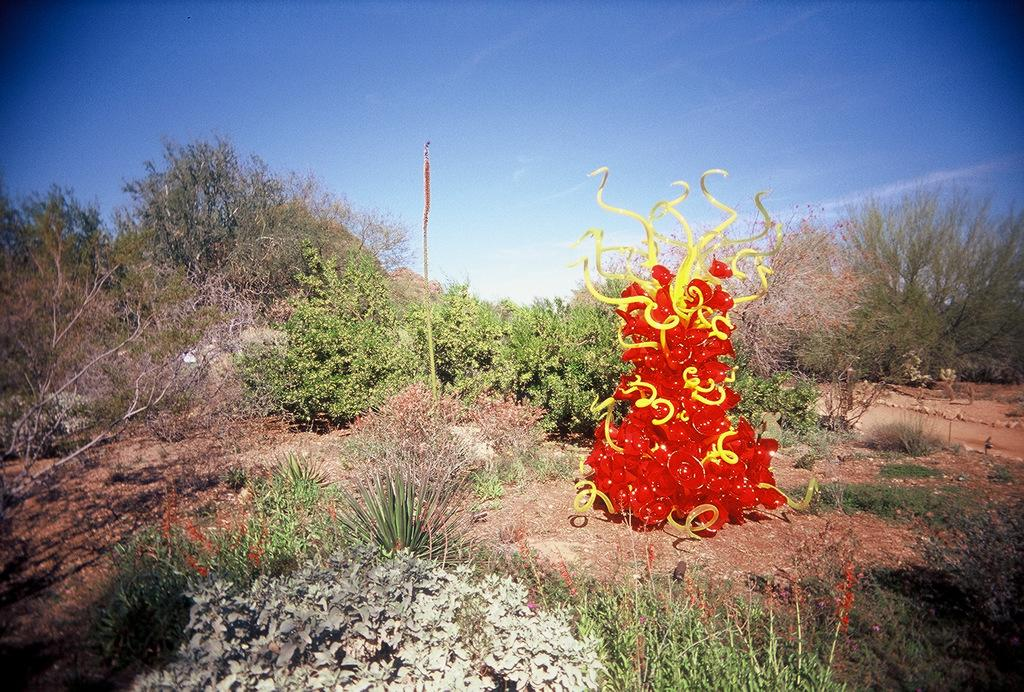What can be seen in the background of the image? There is a sky and trees visible in the background of the image. What other elements are present in the image? There are plants in the image. Can you describe the colorful tree in the image? The colorful tree has yellow and red colors. What type of crime is being committed in the image? There is no crime present in the image; it features a colorful tree and other natural elements. Is there a club visible in the image? There is no club present in the image. 